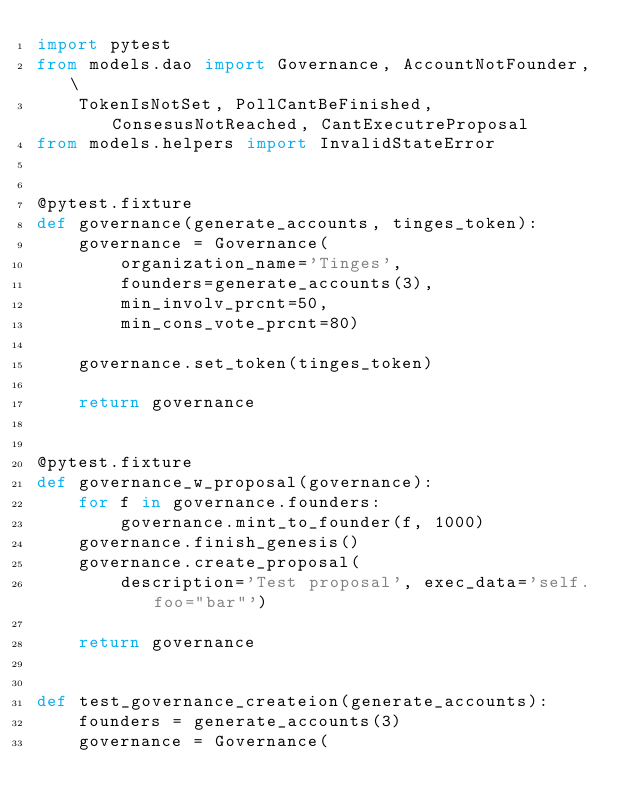<code> <loc_0><loc_0><loc_500><loc_500><_Python_>import pytest
from models.dao import Governance, AccountNotFounder, \
    TokenIsNotSet, PollCantBeFinished, ConsesusNotReached, CantExecutreProposal
from models.helpers import InvalidStateError


@pytest.fixture
def governance(generate_accounts, tinges_token):
    governance = Governance(
        organization_name='Tinges',
        founders=generate_accounts(3),
        min_involv_prcnt=50,
        min_cons_vote_prcnt=80)

    governance.set_token(tinges_token)

    return governance


@pytest.fixture
def governance_w_proposal(governance):
    for f in governance.founders:
        governance.mint_to_founder(f, 1000)
    governance.finish_genesis()
    governance.create_proposal(
        description='Test proposal', exec_data='self.foo="bar"')

    return governance


def test_governance_createion(generate_accounts):
    founders = generate_accounts(3)
    governance = Governance(</code> 